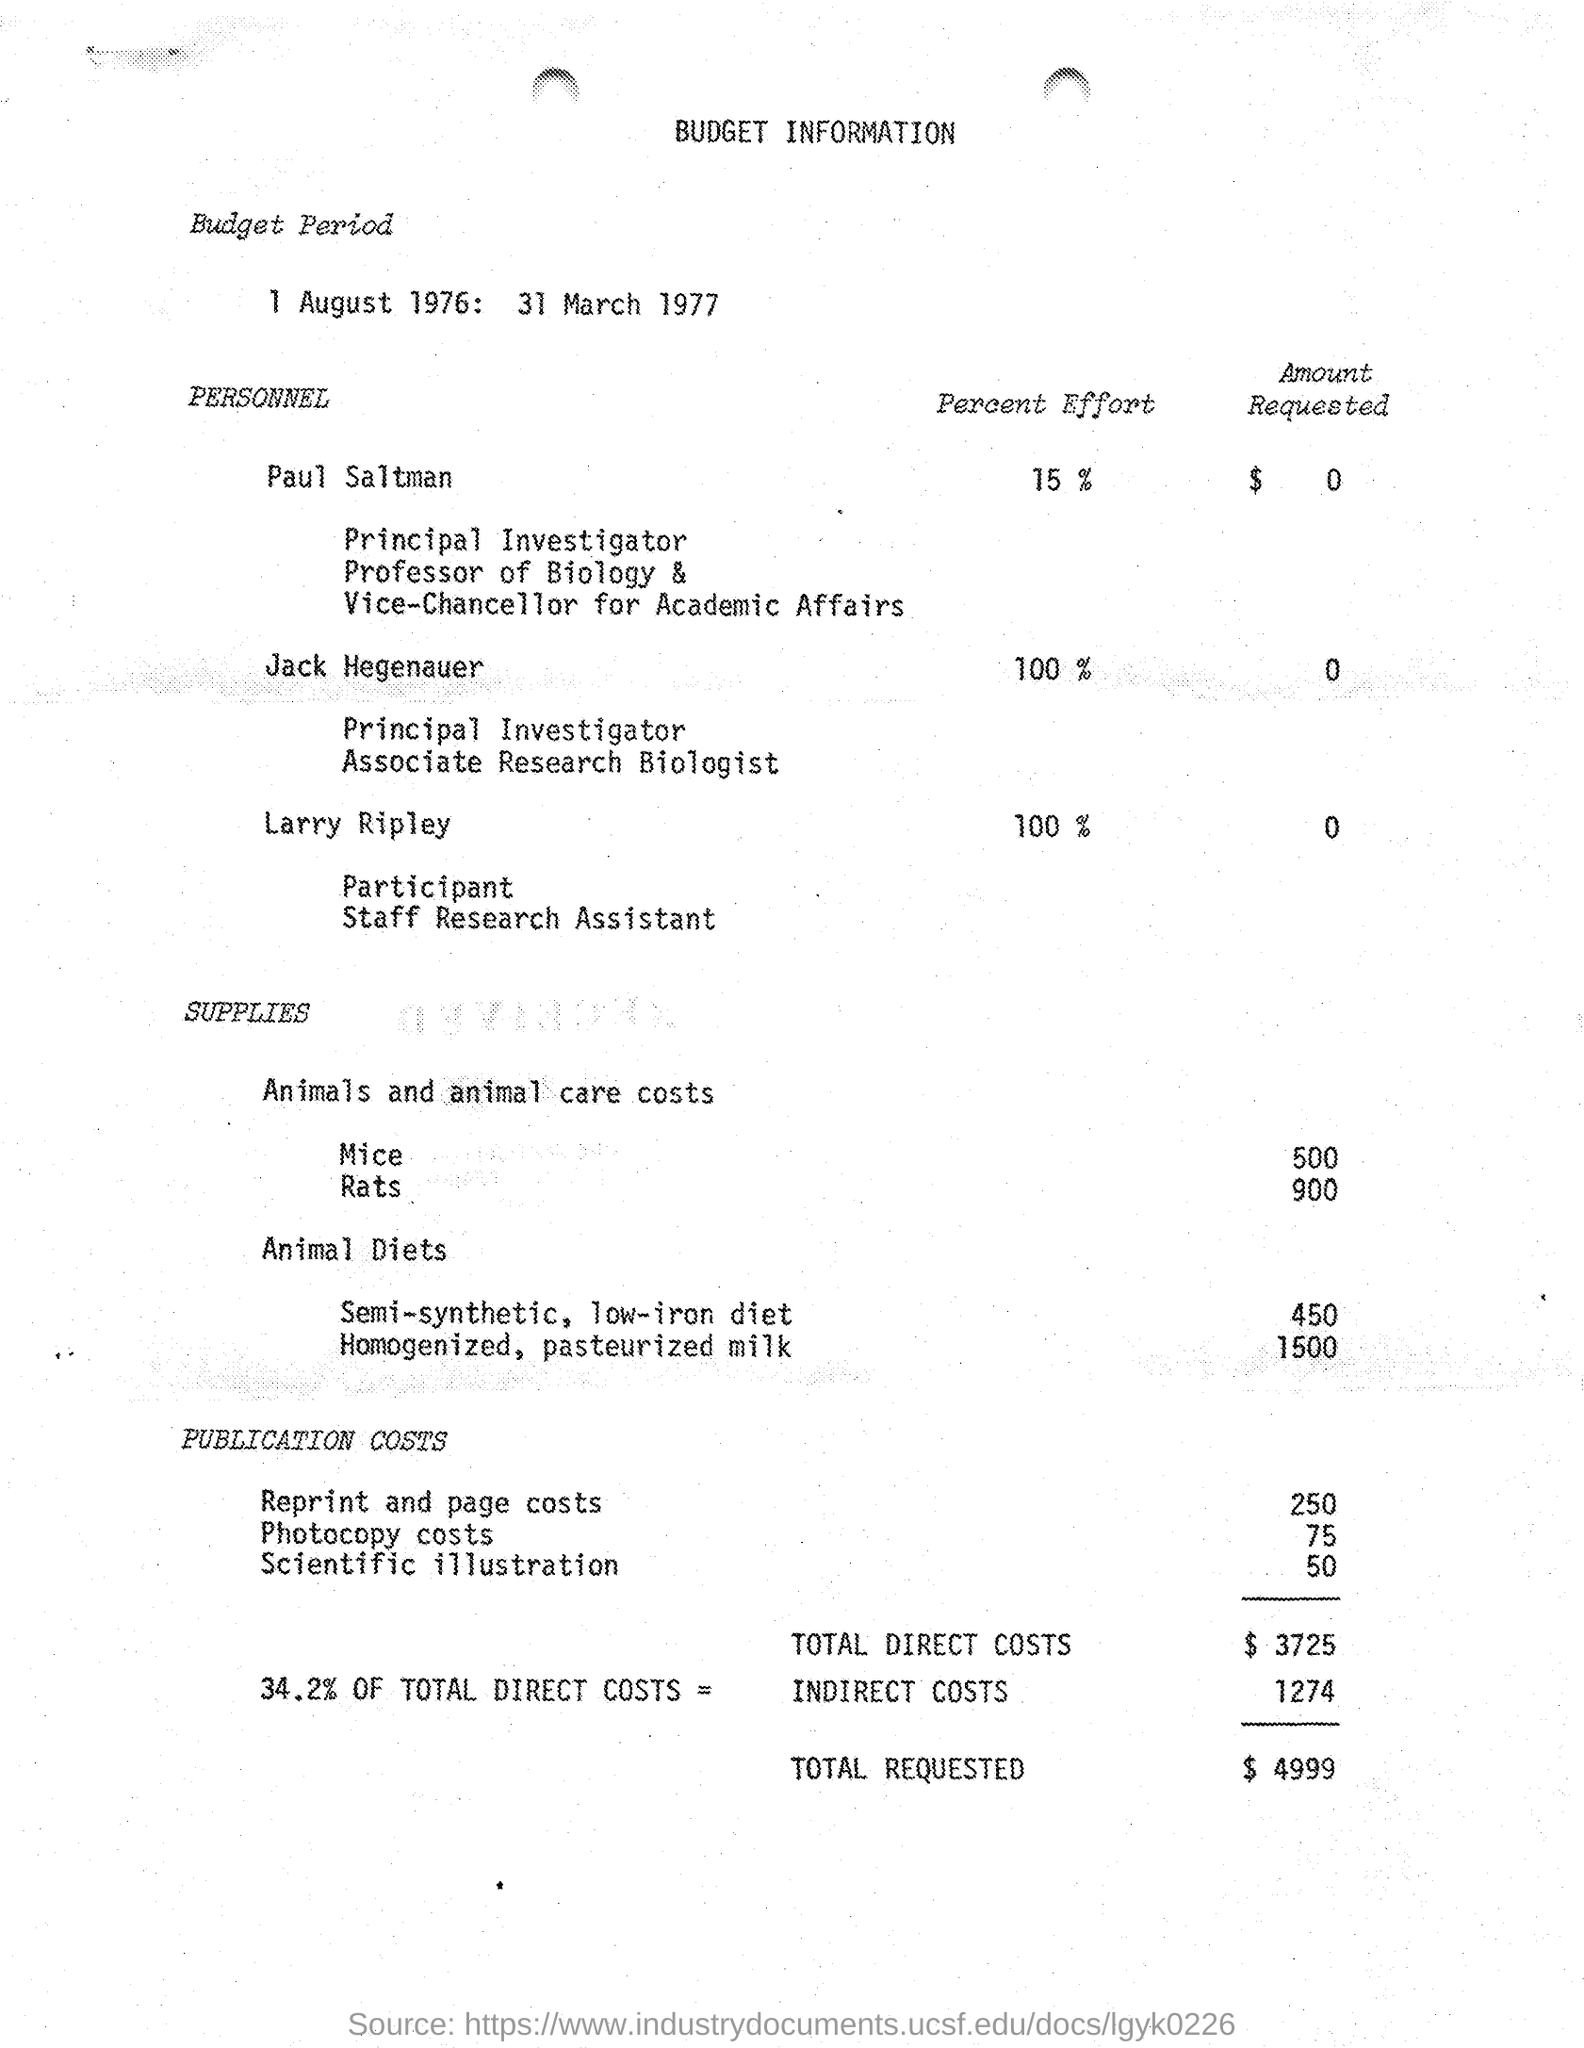What is the Budget Period mentioned in the document?
Your answer should be compact. 1 August 1976: 31 March 1977. What is the designation of Jack Hegenauer?
Ensure brevity in your answer.  Principal investigator Associate Research Biollogist. What Percent effort is given by Jack Hegenauer to the project?
Your response must be concise. 100%. What is the Budget for Reprint and page costs?
Your answer should be very brief. $250. What is the budget for scientific illustration as per the document?
Keep it short and to the point. $50. What is the total requested budget as given in the document?
Offer a terse response. $ 4999. What is the Budget for total direct costs as per the document?
Provide a succinct answer. $3725. What is the amount requested by Larry Ripley as per the document?
Keep it short and to the point. $  0. 